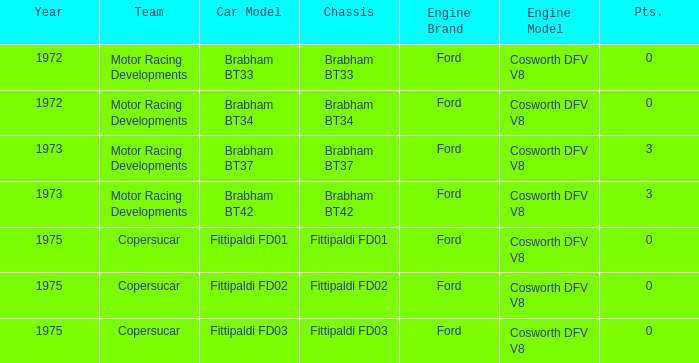Which chassis is more recent than 1972 and has more than 0 Pts. ? Brabham BT37, Brabham BT42. 